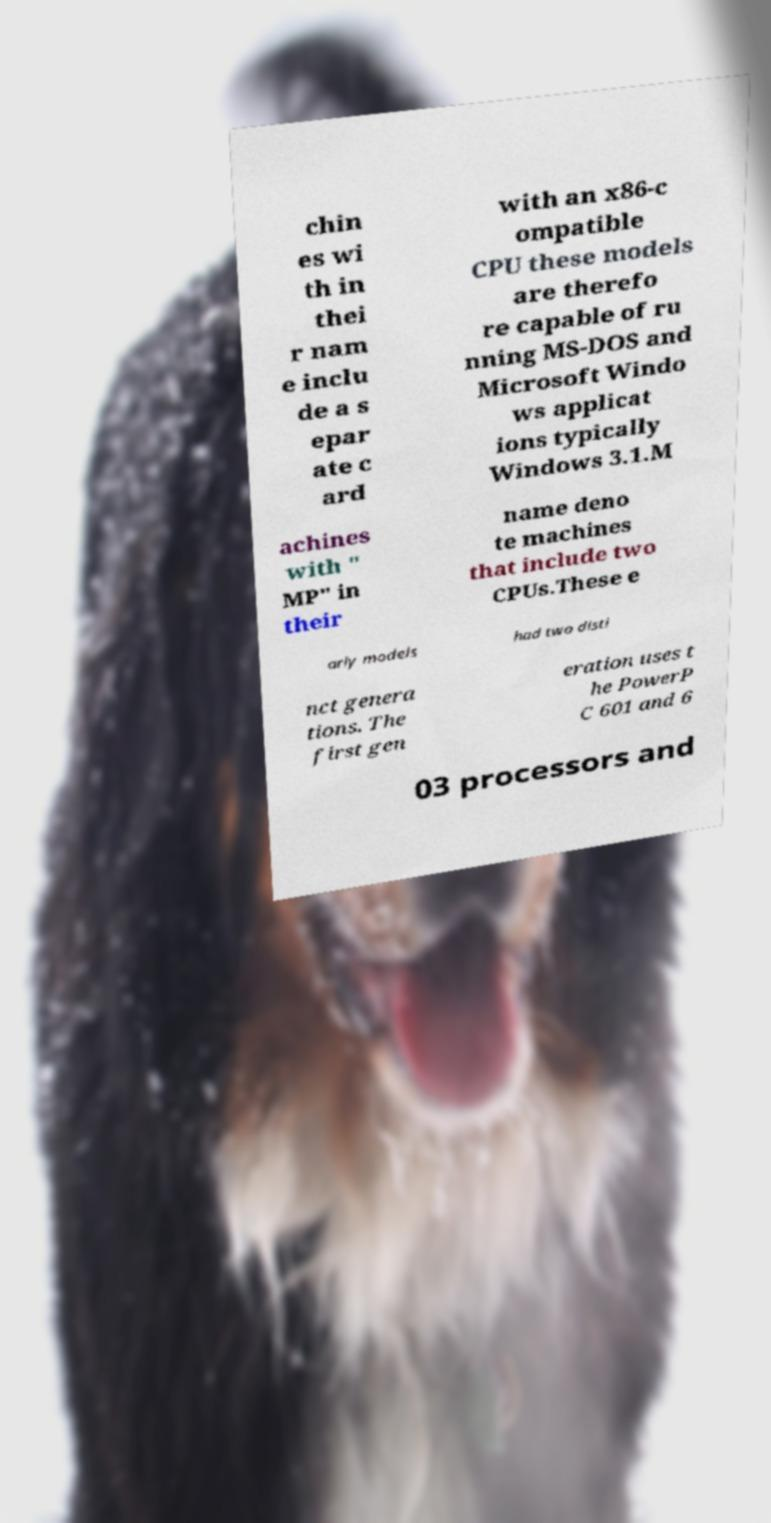For documentation purposes, I need the text within this image transcribed. Could you provide that? chin es wi th in thei r nam e inclu de a s epar ate c ard with an x86-c ompatible CPU these models are therefo re capable of ru nning MS-DOS and Microsoft Windo ws applicat ions typically Windows 3.1.M achines with " MP" in their name deno te machines that include two CPUs.These e arly models had two disti nct genera tions. The first gen eration uses t he PowerP C 601 and 6 03 processors and 